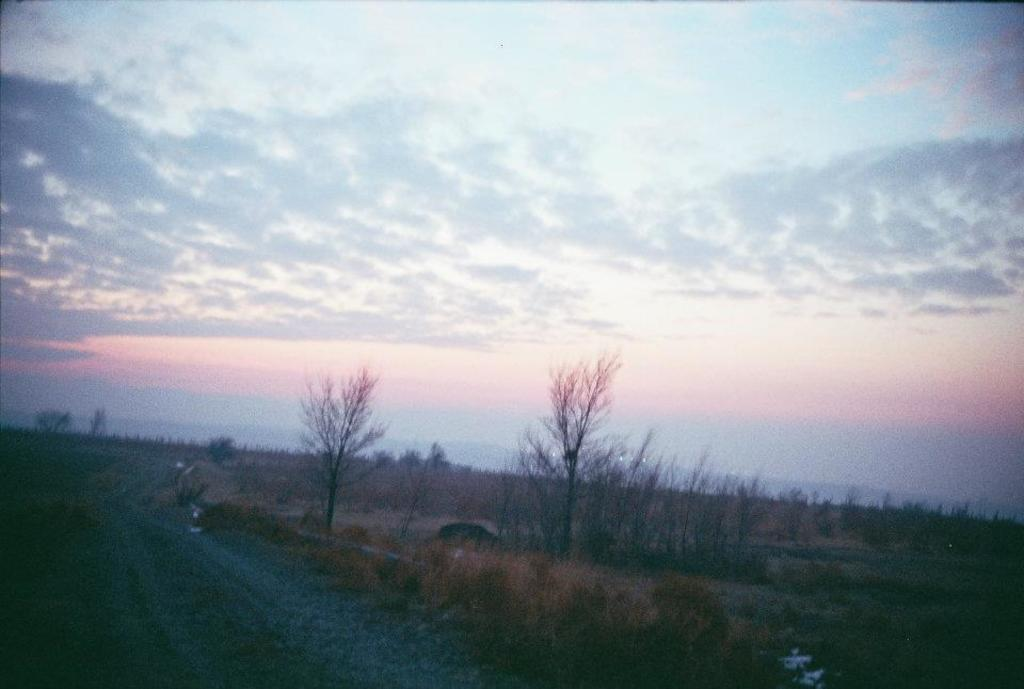What type of vegetation can be seen in the background of the image? There are trees in the background of the image. What is the condition of the sky in the image? The sky is cloudy in the image. How many passengers are visible in the image? There are no passengers present in the image; it only features trees and a cloudy sky. What type of crack can be seen in the image? There is: There is no crack present in the image. 